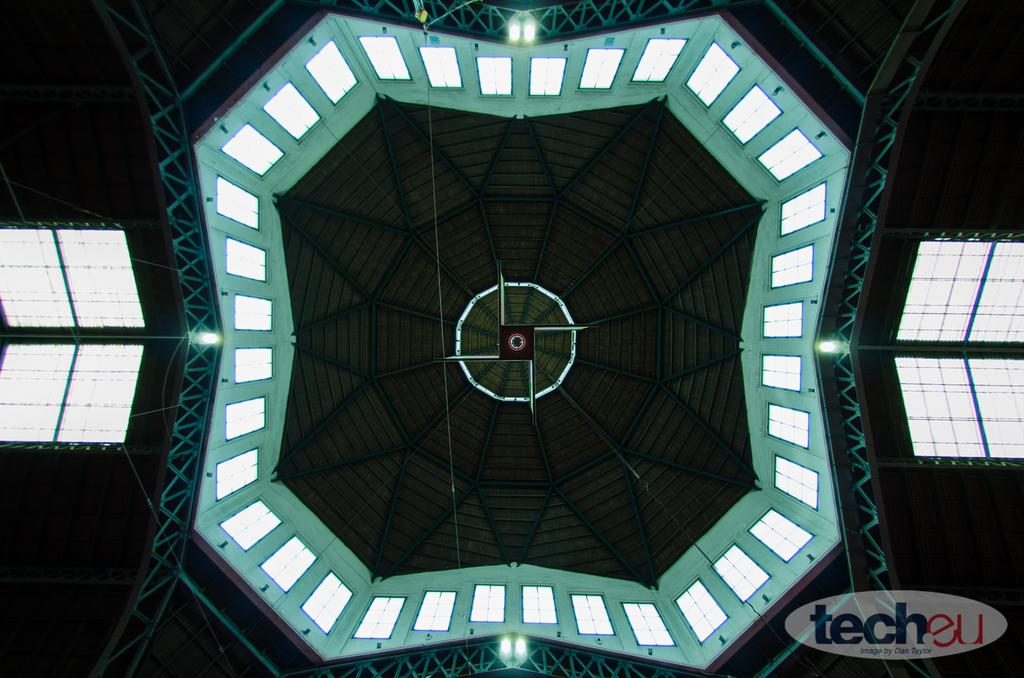What objects can be seen in the image? There are lights and rods in the image. What is the color of the background in the image? The background of the image is dark. Where is the text located in the image? The text is in the bottom right side of the image. What type of watch is mom wearing in the image? There is no watch or mom present in the image; it only features lights, rods, a dark background, and text. 